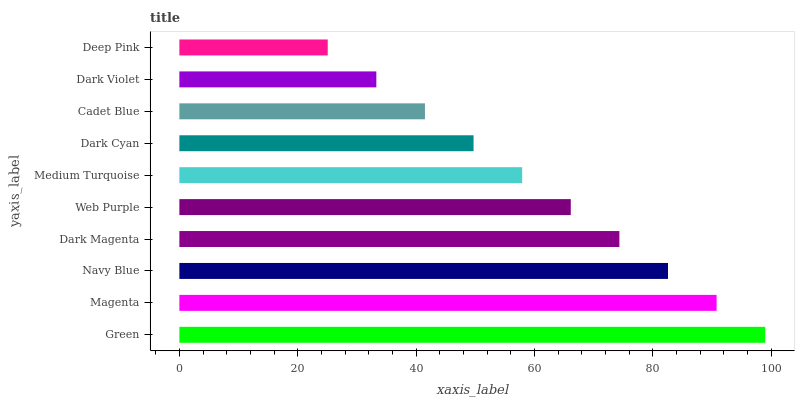Is Deep Pink the minimum?
Answer yes or no. Yes. Is Green the maximum?
Answer yes or no. Yes. Is Magenta the minimum?
Answer yes or no. No. Is Magenta the maximum?
Answer yes or no. No. Is Green greater than Magenta?
Answer yes or no. Yes. Is Magenta less than Green?
Answer yes or no. Yes. Is Magenta greater than Green?
Answer yes or no. No. Is Green less than Magenta?
Answer yes or no. No. Is Web Purple the high median?
Answer yes or no. Yes. Is Medium Turquoise the low median?
Answer yes or no. Yes. Is Dark Cyan the high median?
Answer yes or no. No. Is Cadet Blue the low median?
Answer yes or no. No. 